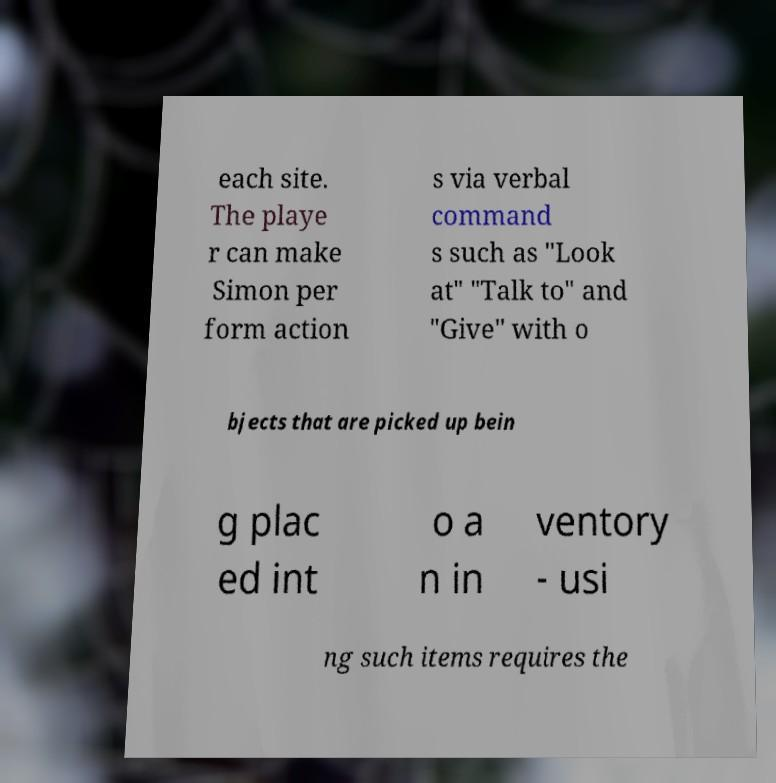For documentation purposes, I need the text within this image transcribed. Could you provide that? each site. The playe r can make Simon per form action s via verbal command s such as "Look at" "Talk to" and "Give" with o bjects that are picked up bein g plac ed int o a n in ventory - usi ng such items requires the 